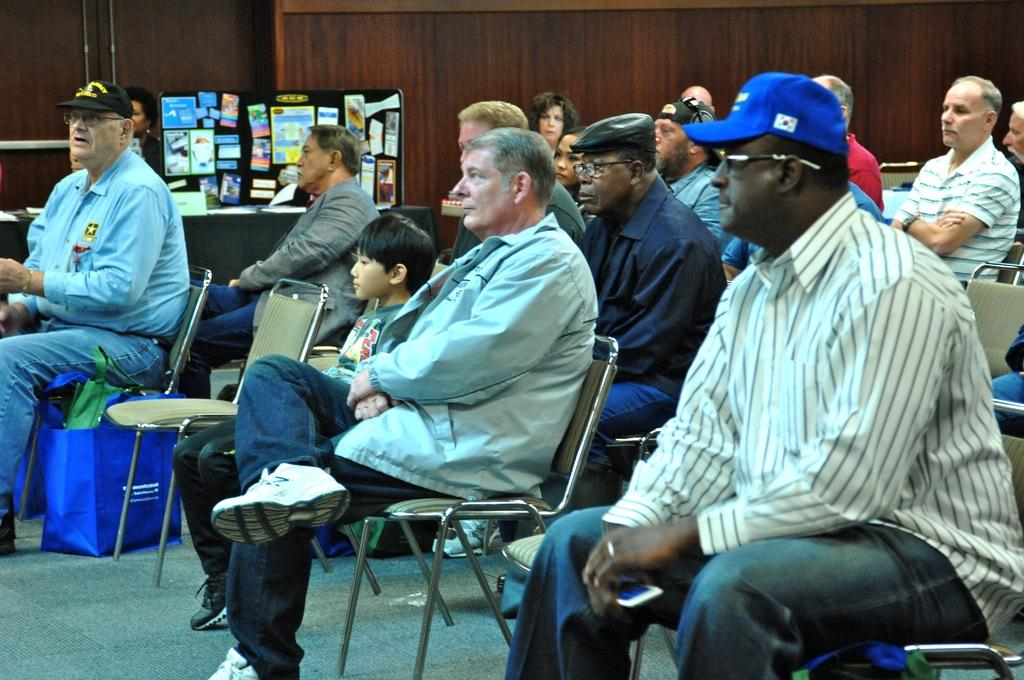What are the people in the image doing? The people in the image are sitting on chairs. Can you describe the attire of some of the people in the image? Some of the people in the image are wearing caps and spectacles. What can be seen in the background of the image? There is a wall, empty chairs, big objects, and some other objects in the background of the image. What type of magic is being performed by the people in the image? There is no indication of magic being performed in the image; the people are simply sitting on chairs. What kind of wood can be seen in the image? There is no wood visible in the image. 